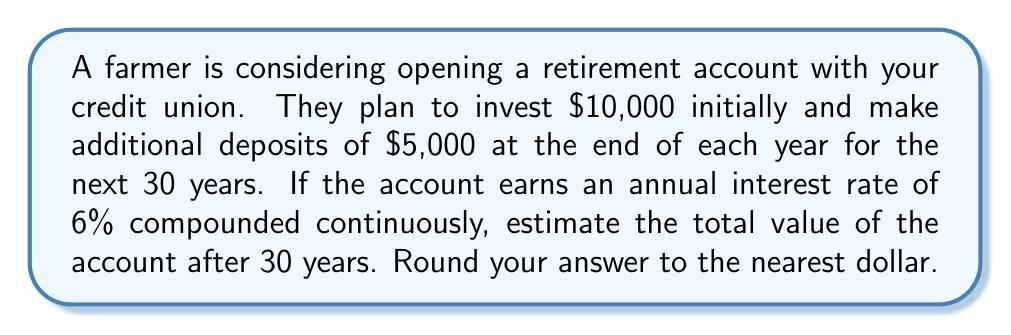What is the answer to this math problem? To solve this problem, we need to use the compound interest formula for continuous compounding and the future value of an annuity formula. Let's break it down step by step:

1. For the initial investment of $10,000:
   We use the continuous compound interest formula:
   $$A = P e^{rt}$$
   where A is the final amount, P is the principal, r is the interest rate, and t is the time in years.

   $$A_1 = 10000 e^{0.06 \times 30} = 10000 e^{1.8} \approx 60,473.14$$

2. For the annual deposits of $5,000:
   We use the future value of an annuity formula with continuous compounding:
   $$A_2 = R \frac{e^{rt} - 1}{e^r - 1}$$
   where R is the regular payment amount, r is the annual interest rate, and t is the number of years.

   $$A_2 = 5000 \frac{e^{0.06 \times 30} - 1}{e^{0.06} - 1} \approx 419,008.39$$

3. The total value of the account is the sum of these two components:
   $$A_{total} = A_1 + A_2 = 60,473.14 + 419,008.39 = 479,481.53$$

Rounding to the nearest dollar gives us $479,482.
Answer: $479,482 